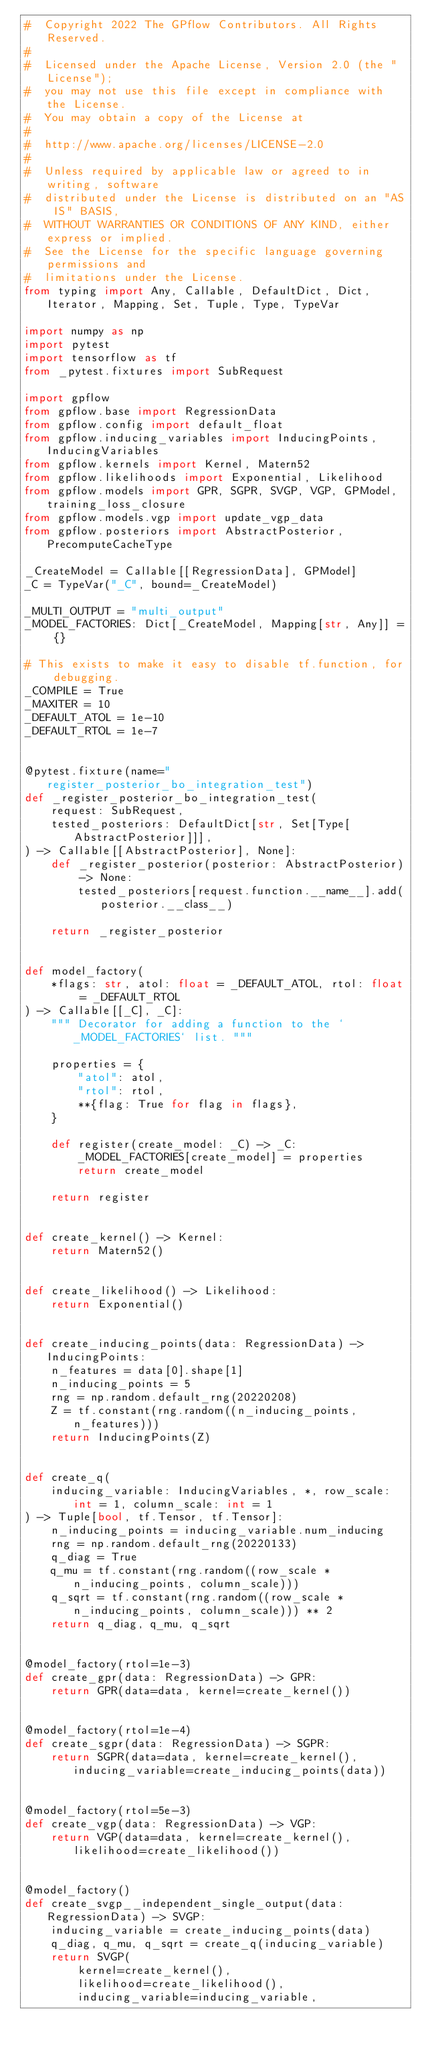<code> <loc_0><loc_0><loc_500><loc_500><_Python_>#  Copyright 2022 The GPflow Contributors. All Rights Reserved.
#
#  Licensed under the Apache License, Version 2.0 (the "License");
#  you may not use this file except in compliance with the License.
#  You may obtain a copy of the License at
#
#  http://www.apache.org/licenses/LICENSE-2.0
#
#  Unless required by applicable law or agreed to in writing, software
#  distributed under the License is distributed on an "AS IS" BASIS,
#  WITHOUT WARRANTIES OR CONDITIONS OF ANY KIND, either express or implied.
#  See the License for the specific language governing permissions and
#  limitations under the License.
from typing import Any, Callable, DefaultDict, Dict, Iterator, Mapping, Set, Tuple, Type, TypeVar

import numpy as np
import pytest
import tensorflow as tf
from _pytest.fixtures import SubRequest

import gpflow
from gpflow.base import RegressionData
from gpflow.config import default_float
from gpflow.inducing_variables import InducingPoints, InducingVariables
from gpflow.kernels import Kernel, Matern52
from gpflow.likelihoods import Exponential, Likelihood
from gpflow.models import GPR, SGPR, SVGP, VGP, GPModel, training_loss_closure
from gpflow.models.vgp import update_vgp_data
from gpflow.posteriors import AbstractPosterior, PrecomputeCacheType

_CreateModel = Callable[[RegressionData], GPModel]
_C = TypeVar("_C", bound=_CreateModel)

_MULTI_OUTPUT = "multi_output"
_MODEL_FACTORIES: Dict[_CreateModel, Mapping[str, Any]] = {}

# This exists to make it easy to disable tf.function, for debugging.
_COMPILE = True
_MAXITER = 10
_DEFAULT_ATOL = 1e-10
_DEFAULT_RTOL = 1e-7


@pytest.fixture(name="register_posterior_bo_integration_test")
def _register_posterior_bo_integration_test(
    request: SubRequest,
    tested_posteriors: DefaultDict[str, Set[Type[AbstractPosterior]]],
) -> Callable[[AbstractPosterior], None]:
    def _register_posterior(posterior: AbstractPosterior) -> None:
        tested_posteriors[request.function.__name__].add(posterior.__class__)

    return _register_posterior


def model_factory(
    *flags: str, atol: float = _DEFAULT_ATOL, rtol: float = _DEFAULT_RTOL
) -> Callable[[_C], _C]:
    """ Decorator for adding a function to the `_MODEL_FACTORIES` list. """

    properties = {
        "atol": atol,
        "rtol": rtol,
        **{flag: True for flag in flags},
    }

    def register(create_model: _C) -> _C:
        _MODEL_FACTORIES[create_model] = properties
        return create_model

    return register


def create_kernel() -> Kernel:
    return Matern52()


def create_likelihood() -> Likelihood:
    return Exponential()


def create_inducing_points(data: RegressionData) -> InducingPoints:
    n_features = data[0].shape[1]
    n_inducing_points = 5
    rng = np.random.default_rng(20220208)
    Z = tf.constant(rng.random((n_inducing_points, n_features)))
    return InducingPoints(Z)


def create_q(
    inducing_variable: InducingVariables, *, row_scale: int = 1, column_scale: int = 1
) -> Tuple[bool, tf.Tensor, tf.Tensor]:
    n_inducing_points = inducing_variable.num_inducing
    rng = np.random.default_rng(20220133)
    q_diag = True
    q_mu = tf.constant(rng.random((row_scale * n_inducing_points, column_scale)))
    q_sqrt = tf.constant(rng.random((row_scale * n_inducing_points, column_scale))) ** 2
    return q_diag, q_mu, q_sqrt


@model_factory(rtol=1e-3)
def create_gpr(data: RegressionData) -> GPR:
    return GPR(data=data, kernel=create_kernel())


@model_factory(rtol=1e-4)
def create_sgpr(data: RegressionData) -> SGPR:
    return SGPR(data=data, kernel=create_kernel(), inducing_variable=create_inducing_points(data))


@model_factory(rtol=5e-3)
def create_vgp(data: RegressionData) -> VGP:
    return VGP(data=data, kernel=create_kernel(), likelihood=create_likelihood())


@model_factory()
def create_svgp__independent_single_output(data: RegressionData) -> SVGP:
    inducing_variable = create_inducing_points(data)
    q_diag, q_mu, q_sqrt = create_q(inducing_variable)
    return SVGP(
        kernel=create_kernel(),
        likelihood=create_likelihood(),
        inducing_variable=inducing_variable,</code> 